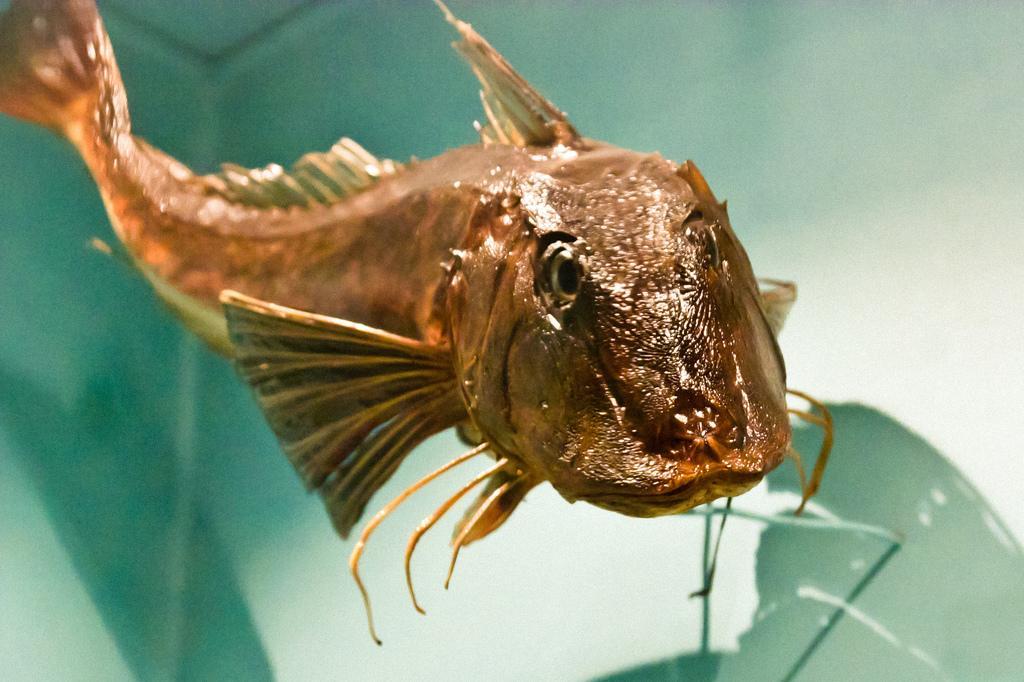Can you describe this image briefly? In this image we can see a fish in water. 